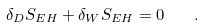Convert formula to latex. <formula><loc_0><loc_0><loc_500><loc_500>\delta _ { D } S _ { E H } + \delta _ { W } S _ { E H } = 0 \quad .</formula> 